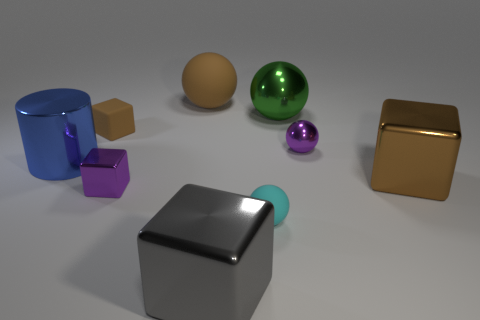Subtract 1 balls. How many balls are left? 3 Subtract all green cubes. Subtract all cyan balls. How many cubes are left? 4 Subtract all balls. How many objects are left? 5 Add 1 small rubber blocks. How many small rubber blocks are left? 2 Add 1 tiny green rubber things. How many tiny green rubber things exist? 1 Subtract 0 green cylinders. How many objects are left? 9 Subtract all big purple cylinders. Subtract all blue shiny objects. How many objects are left? 8 